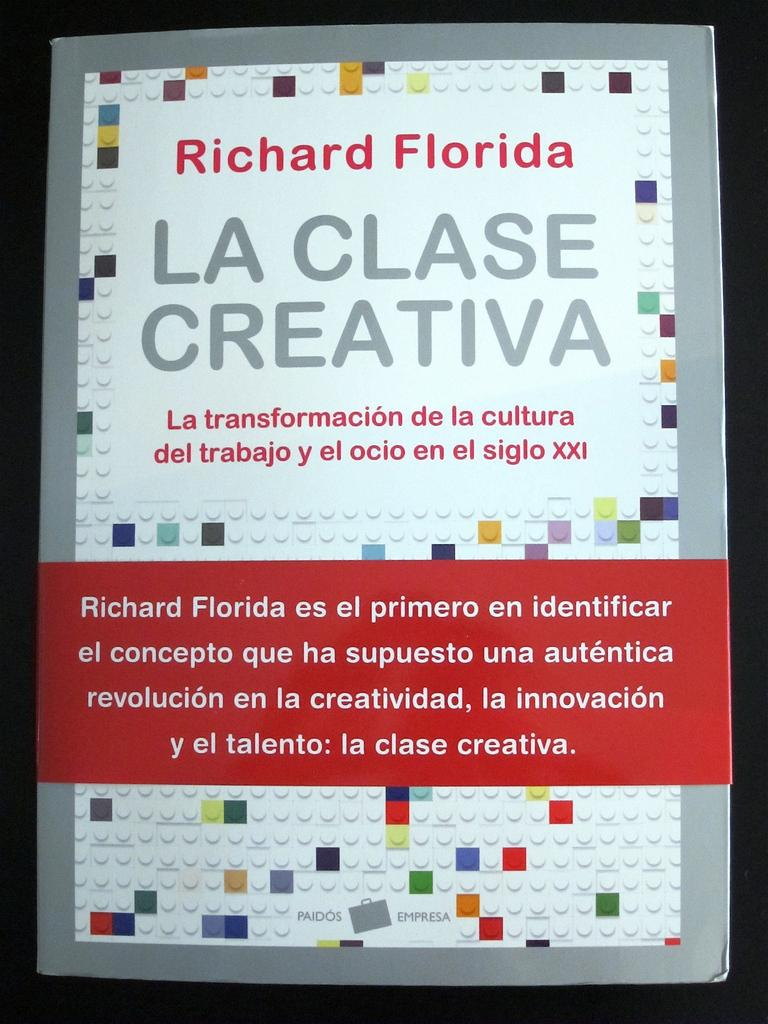<image>
Share a concise interpretation of the image provided. An advertisement poster for Richard Florida uses LEGO bricks as a background. 